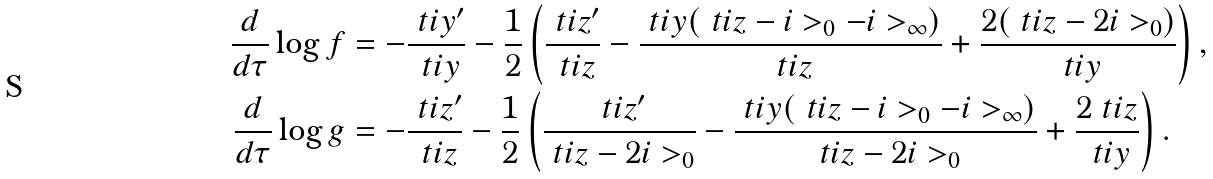Convert formula to latex. <formula><loc_0><loc_0><loc_500><loc_500>\frac { d } { d \tau } \log { f } & = - \frac { \ t i { y } ^ { \prime } } { \ t i { y } } - \frac { 1 } { 2 } \left ( \frac { \ t i { z } ^ { \prime } } { \ t i { z } } - \frac { \ t i { y } ( \ t i { z } - i > _ { 0 } - i > _ { \infty } ) } { \ t i { z } } + \frac { 2 ( \ t i { z } - 2 i > _ { 0 } ) } { \ t i { y } } \right ) , \\ \frac { d } { d \tau } \log { g } & = - \frac { \ t i { z } ^ { \prime } } { \ t i { z } } - \frac { 1 } { 2 } \left ( \frac { \ t i { z } ^ { \prime } } { \ t i { z } - 2 i > _ { 0 } } - \frac { \ t i { y } ( \ t i { z } - i > _ { 0 } - i > _ { \infty } ) } { \ t i { z } - 2 i > _ { 0 } } + \frac { 2 \ t i { z } } { \ t i { y } } \right ) .</formula> 